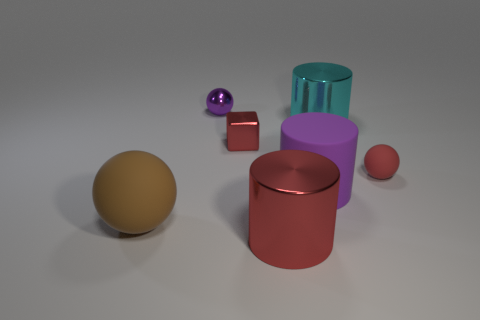Does the small cube have the same color as the small rubber sphere?
Provide a succinct answer. Yes. What size is the red cube that is made of the same material as the purple sphere?
Provide a succinct answer. Small. What number of tiny metallic objects are behind the small red thing in front of the small red object that is on the left side of the cyan shiny thing?
Give a very brief answer. 2. Is the color of the small cube the same as the tiny object in front of the small cube?
Provide a succinct answer. Yes. There is a small metal object that is the same color as the tiny rubber thing; what is its shape?
Your response must be concise. Cube. There is a tiny red object that is to the right of the shiny cylinder that is in front of the large cylinder right of the purple cylinder; what is it made of?
Offer a terse response. Rubber. Is the shape of the big object that is behind the matte cylinder the same as  the large purple matte object?
Offer a very short reply. Yes. What material is the thing in front of the brown rubber ball?
Ensure brevity in your answer.  Metal. What number of rubber things are purple cylinders or tiny blue balls?
Provide a succinct answer. 1. Is there a red thing of the same size as the purple shiny sphere?
Your response must be concise. Yes. 